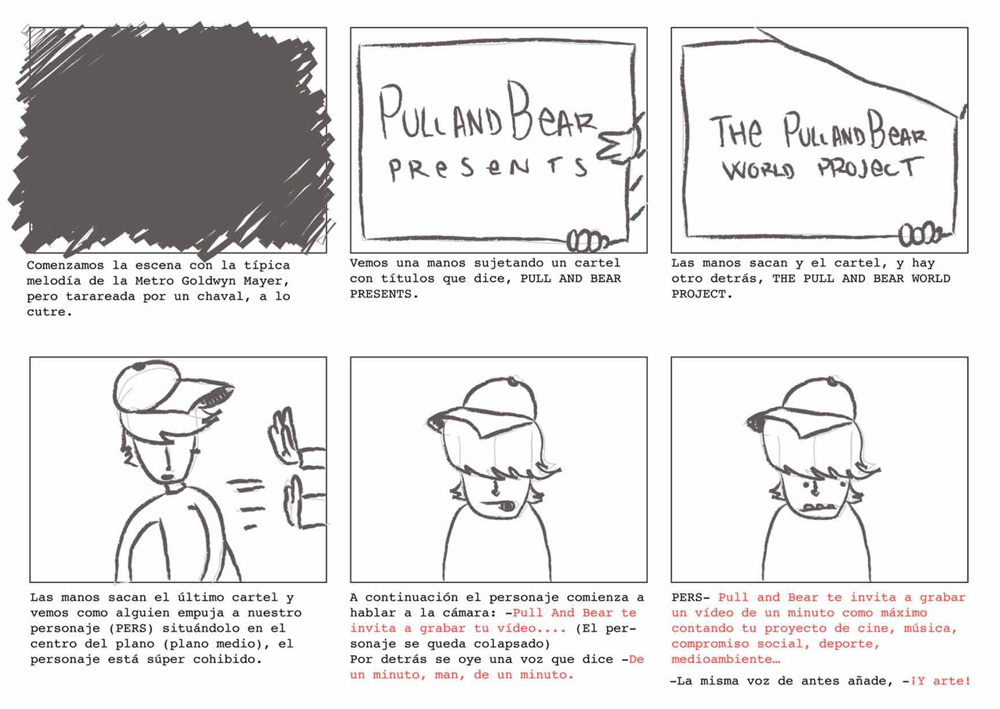How does the character's body language throughout the comic strip inform us about his personality? The character exhibits a body language that conveys hesitance and humility, notably through his downcast eyes and the way he holds the poster slightly shielding himself. This body language indicates that the character might be introverted or not entirely comfortable in spotlight situations, which gives us insight into a personality that, while possibly shy, is willing to step forward when it matters. 